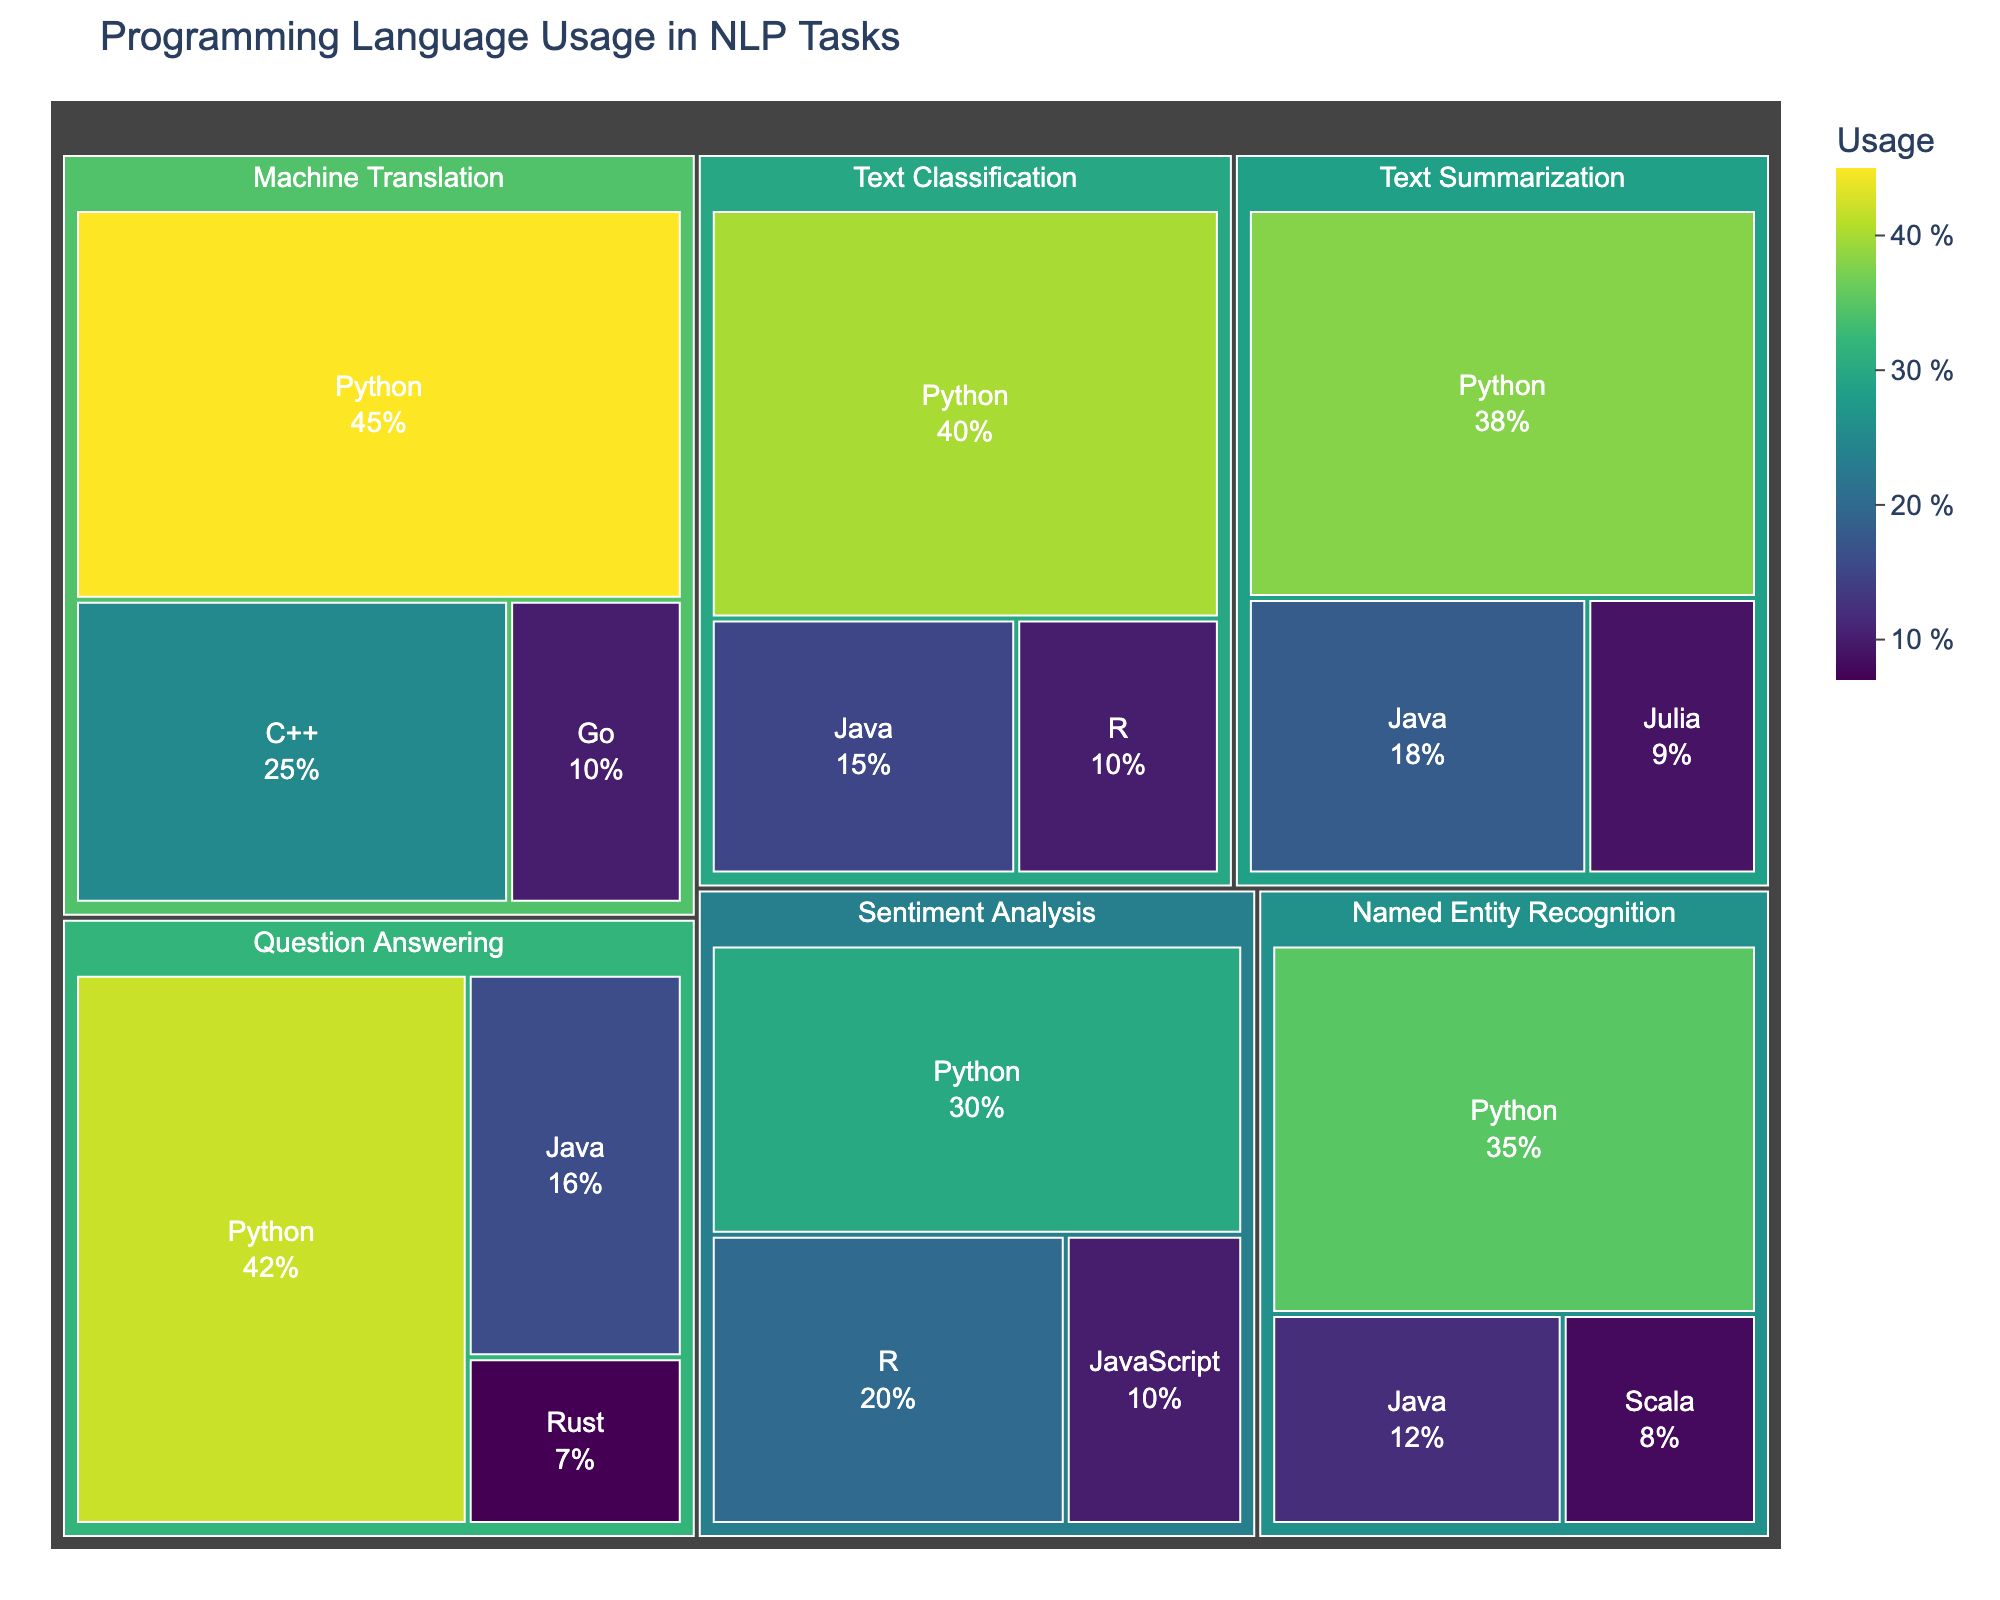What is the most used programming language across all tasks? The treemap shows different tasks and the usage percentage of each language within those tasks. The language with the largest total usage percentage across all tasks is Python, as it appears to have the highest usage in all task categories.
Answer: Python Which task has the highest total usage percentage of Java? By examining the Java sections across all tasks, we see that Text Summarization (18%) has the highest usage percentage of Java compared to the other tasks.
Answer: Text Summarization What is the combined usage percentage for Python in Text Classification and Named Entity Recognition? The usage percentage for Python in Text Classification is 40%, and in Named Entity Recognition, it is 35%. Adding these together gives a total of 40% + 35% = 75%.
Answer: 75% Compare the usage percentages for Python and R in Sentiment Analysis. Which one is higher and by how much? Python has 30% usage and R has 20% usage for Sentiment Analysis. The difference is 30% - 20% = 10%, indicating Python has a higher usage by 10%.
Answer: Python is higher by 10% What is the least used language in Machine Translation? The languages used in Machine Translation are Python (45%), C++ (25%), and Go (10%). The least used language is Go with 10% usage.
Answer: Go How does the usage of Java in Question Answering compare to that in Named Entity Recognition? Java has a 16% usage in Question Answering and 12% in Named Entity Recognition. Therefore, it has a 4% higher usage in Question Answering (16% - 12%).
Answer: Java is higher by 4% Calculate the average usage percentage of languages in Text Summarization. The usage percentages for Text Summarization are Python (38%), Java (18%), and Julia (9%). The average is calculated as (38% + 18% + 9%) / 3 = 65 / 3 = 21.67%.
Answer: 21.67% Which language is used exclusively in one specific task and not in any other task? Rust is used exclusively in the Question Answering task with a usage percentage of 7% and does not appear in any other task.
Answer: Rust What is the total usage percentage of Python across all tasks? Python usage percentages across tasks are: Text Classification (40%), Named Entity Recognition (35%), Sentiment Analysis (30%), Machine Translation (45%), Text Summarization (38%), and Question Answering (42%). Adding these, we get 40% + 35% + 30% + 45% + 38% + 42% = 230%.
Answer: 230% Which task shows the smallest variety of programming languages used and how many languages does it include? Named Entity Recognition involves Python (35%), Java (12%), and Scala (8%), totaling three languages, which is fewer than other tasks like Text Classification, which involves three as well, but Task Summarization and Machine Translation involve more languages.
Answer: Named Entity Recognition with 3 languages 